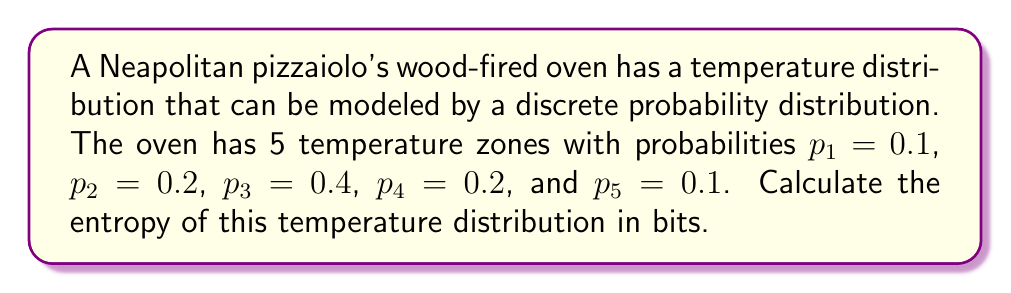Provide a solution to this math problem. To calculate the entropy of the pizza oven's heat distribution, we'll use the formula for Shannon entropy:

$$H = -\sum_{i=1}^n p_i \log_2(p_i)$$

Where $p_i$ is the probability of each temperature zone and $n$ is the number of zones.

Let's calculate each term:

1. $-p_1 \log_2(p_1) = -0.1 \log_2(0.1) = 0.332$
2. $-p_2 \log_2(p_2) = -0.2 \log_2(0.2) = 0.464$
3. $-p_3 \log_2(p_3) = -0.4 \log_2(0.4) = 0.528$
4. $-p_4 \log_2(p_4) = -0.2 \log_2(0.2) = 0.464$
5. $-p_5 \log_2(p_5) = -0.1 \log_2(0.1) = 0.332$

Now, sum all these terms:

$$H = 0.332 + 0.464 + 0.528 + 0.464 + 0.332 = 2.12$$

Therefore, the entropy of the pizza oven's heat distribution is approximately 2.12 bits.
Answer: 2.12 bits 